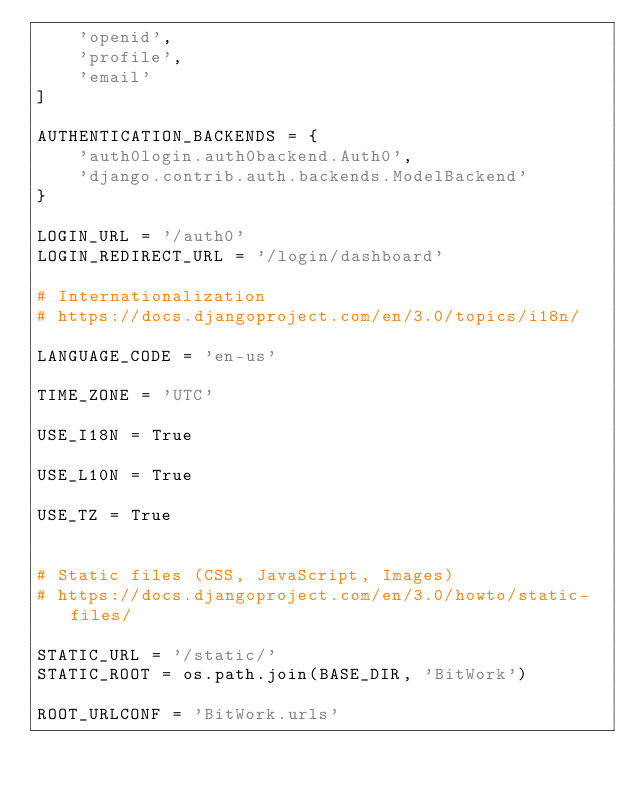<code> <loc_0><loc_0><loc_500><loc_500><_Python_>    'openid',
    'profile',
    'email'
]

AUTHENTICATION_BACKENDS = {
    'auth0login.auth0backend.Auth0',
    'django.contrib.auth.backends.ModelBackend'
}

LOGIN_URL = '/auth0'
LOGIN_REDIRECT_URL = '/login/dashboard'

# Internationalization
# https://docs.djangoproject.com/en/3.0/topics/i18n/

LANGUAGE_CODE = 'en-us'

TIME_ZONE = 'UTC'

USE_I18N = True

USE_L10N = True

USE_TZ = True


# Static files (CSS, JavaScript, Images)
# https://docs.djangoproject.com/en/3.0/howto/static-files/

STATIC_URL = '/static/'
STATIC_ROOT = os.path.join(BASE_DIR, 'BitWork')

ROOT_URLCONF = 'BitWork.urls'

</code> 